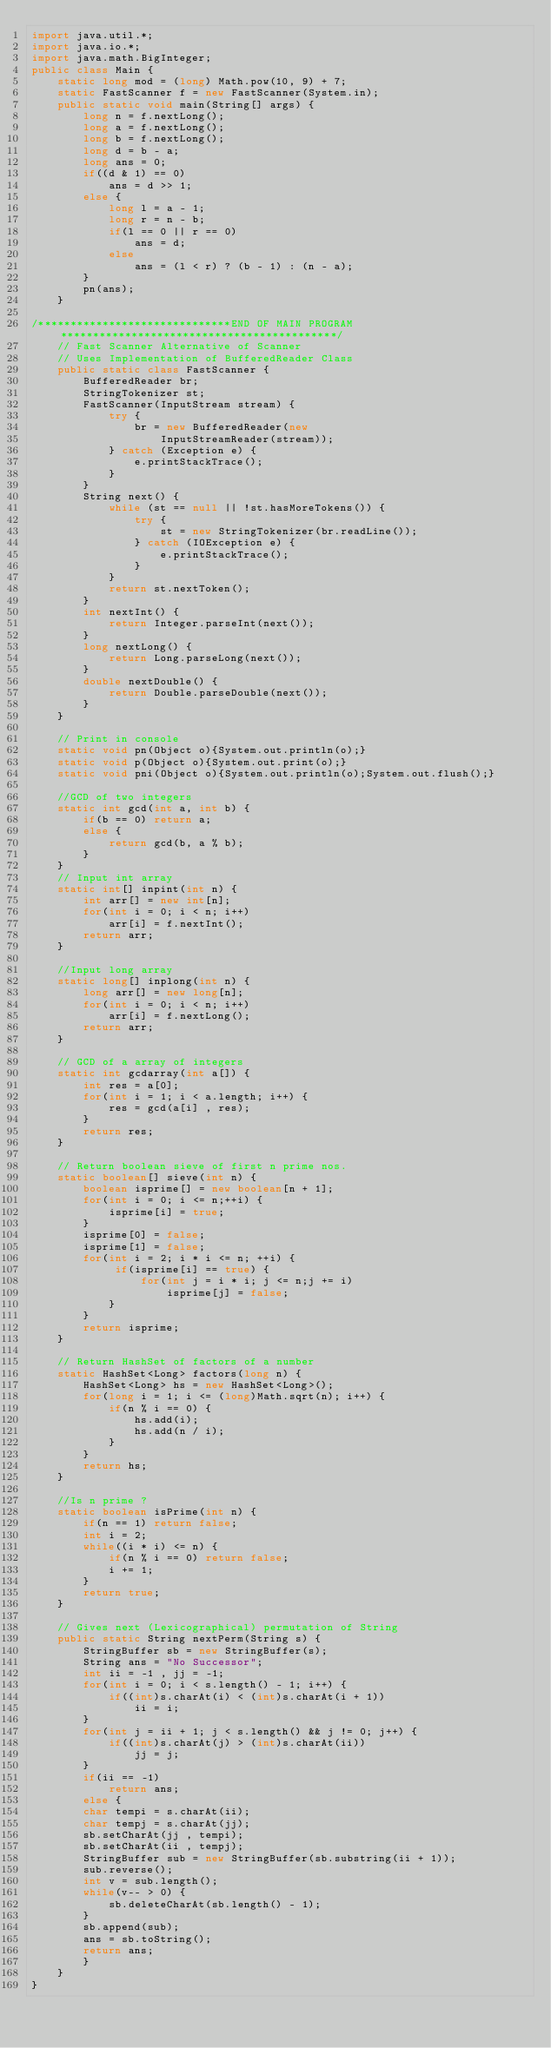Convert code to text. <code><loc_0><loc_0><loc_500><loc_500><_Java_>import java.util.*;
import java.io.*;
import java.math.BigInteger;
public class Main {
    static long mod = (long) Math.pow(10, 9) + 7;
    static FastScanner f = new FastScanner(System.in);
    public static void main(String[] args) {
        long n = f.nextLong();
        long a = f.nextLong();
        long b = f.nextLong();
        long d = b - a;
        long ans = 0;
        if((d & 1) == 0)
            ans = d >> 1;
        else {
            long l = a - 1;
            long r = n - b;
            if(l == 0 || r == 0)
                ans = d;
            else
                ans = (l < r) ? (b - 1) : (n - a);
        }
        pn(ans);
    }
        
/******************************END OF MAIN PROGRAM*******************************************/
    // Fast Scanner Alternative of Scanner 
    // Uses Implementation of BufferedReader Class
    public static class FastScanner {
        BufferedReader br;
        StringTokenizer st;
        FastScanner(InputStream stream) {
            try {
                br = new BufferedReader(new
                    InputStreamReader(stream));
            } catch (Exception e) {
                e.printStackTrace();
            }
        }
        String next() {
            while (st == null || !st.hasMoreTokens()) {
                try {
                    st = new StringTokenizer(br.readLine());
                } catch (IOException e) {
                    e.printStackTrace();
                }
            }
            return st.nextToken();
        }
        int nextInt() {
            return Integer.parseInt(next());
        }
        long nextLong() {
            return Long.parseLong(next());
        }
        double nextDouble() {
            return Double.parseDouble(next());
        }
    }
    
    // Print in console
    static void pn(Object o){System.out.println(o);}
    static void p(Object o){System.out.print(o);}
    static void pni(Object o){System.out.println(o);System.out.flush();}

    //GCD of two integers
    static int gcd(int a, int b) {
        if(b == 0) return a;
        else {
            return gcd(b, a % b);
        }
    }
    // Input int array
    static int[] inpint(int n) {
        int arr[] = new int[n];
        for(int i = 0; i < n; i++) 
            arr[i] = f.nextInt();
        return arr;
    }

    //Input long array
    static long[] inplong(int n) {
        long arr[] = new long[n];
        for(int i = 0; i < n; i++) 
            arr[i] = f.nextLong();
        return arr;
    }

    // GCD of a array of integers
    static int gcdarray(int a[]) {
        int res = a[0];
        for(int i = 1; i < a.length; i++) {
            res = gcd(a[i] , res);
        }
        return res;
    }
    
    // Return boolean sieve of first n prime nos.
    static boolean[] sieve(int n) {
        boolean isprime[] = new boolean[n + 1];
        for(int i = 0; i <= n;++i) {
            isprime[i] = true;
        }
        isprime[0] = false;
        isprime[1] = false;
        for(int i = 2; i * i <= n; ++i) {
             if(isprime[i] == true) {               
                 for(int j = i * i; j <= n;j += i)
                     isprime[j] = false;
            }
        }
        return isprime;
    }

    // Return HashSet of factors of a number
    static HashSet<Long> factors(long n) {
        HashSet<Long> hs = new HashSet<Long>();
        for(long i = 1; i <= (long)Math.sqrt(n); i++) {
            if(n % i == 0) {
                hs.add(i);
                hs.add(n / i);
            }
        }
        return hs;
    }

    //Is n prime ?
    static boolean isPrime(int n) {
        if(n == 1) return false;
        int i = 2;
        while((i * i) <= n) {
            if(n % i == 0) return false;
            i += 1;
        }
        return true;
    }

    // Gives next (Lexicographical) permutation of String
    public static String nextPerm(String s) {
        StringBuffer sb = new StringBuffer(s);
        String ans = "No Successor";
        int ii = -1 , jj = -1;
        for(int i = 0; i < s.length() - 1; i++) {
            if((int)s.charAt(i) < (int)s.charAt(i + 1))
                ii = i;
        }
        for(int j = ii + 1; j < s.length() && j != 0; j++) {
            if((int)s.charAt(j) > (int)s.charAt(ii))
                jj = j;
        }
        if(ii == -1)
            return ans;
        else {
        char tempi = s.charAt(ii);
        char tempj = s.charAt(jj);
        sb.setCharAt(jj , tempi);
        sb.setCharAt(ii , tempj);
        StringBuffer sub = new StringBuffer(sb.substring(ii + 1));
        sub.reverse();
        int v = sub.length();
        while(v-- > 0) {
            sb.deleteCharAt(sb.length() - 1);
        }
        sb.append(sub);
        ans = sb.toString();
        return ans;
        }
    }
}</code> 